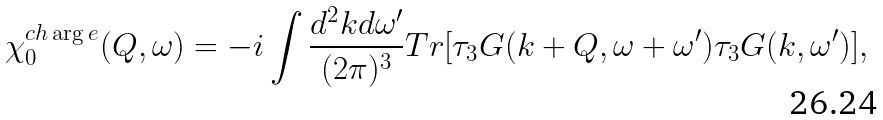<formula> <loc_0><loc_0><loc_500><loc_500>\chi _ { 0 } ^ { c h \arg e } ( { Q } , \omega ) = - i \int \frac { d ^ { 2 } k d \omega ^ { \prime } } { ( 2 \pi ) ^ { 3 } } T r [ \tau _ { 3 } G ( { k } + { Q } , \omega + \omega ^ { \prime } ) \tau _ { 3 } G ( { k } , \omega ^ { \prime } ) ] ,</formula> 